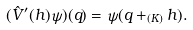<formula> <loc_0><loc_0><loc_500><loc_500>( \hat { V } ^ { \prime } ( h ) \psi ) ( q ) = \psi ( q + _ { ( K ) } h ) .</formula> 